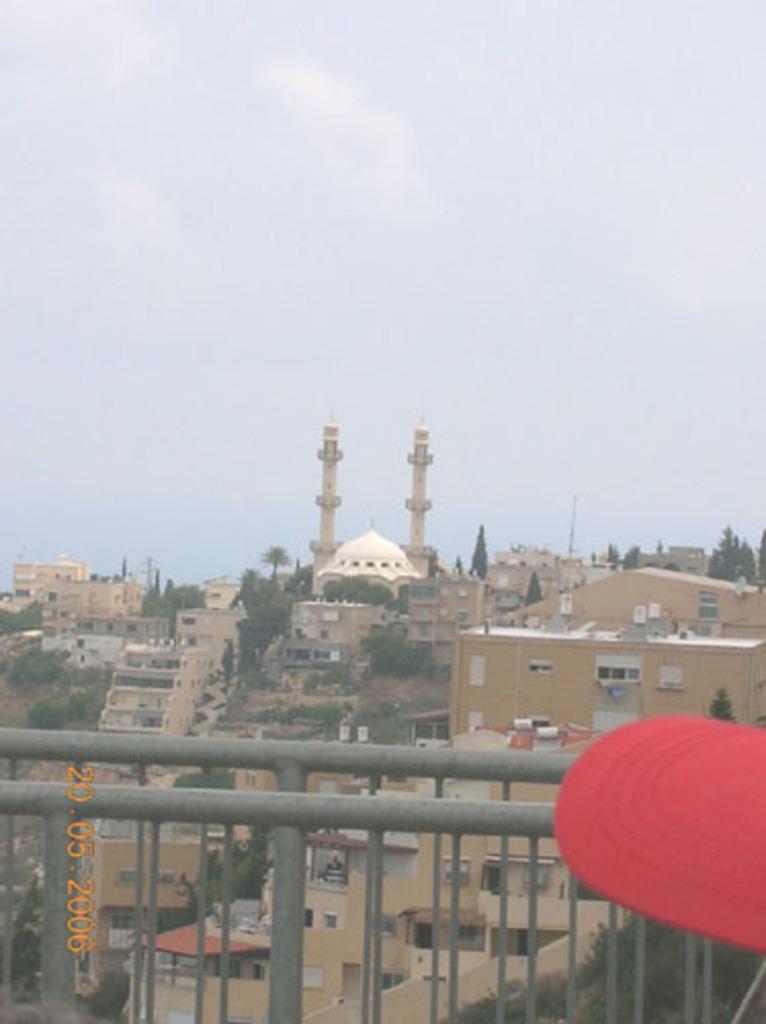Describe this image in one or two sentences. In this picture I can see buildings, trees and I can see couple of towers and I can see a metal fence and text at the bottom left corner of the picture and looks like a red color cap at the bottom right corner and I can see blue cloudy sky. 